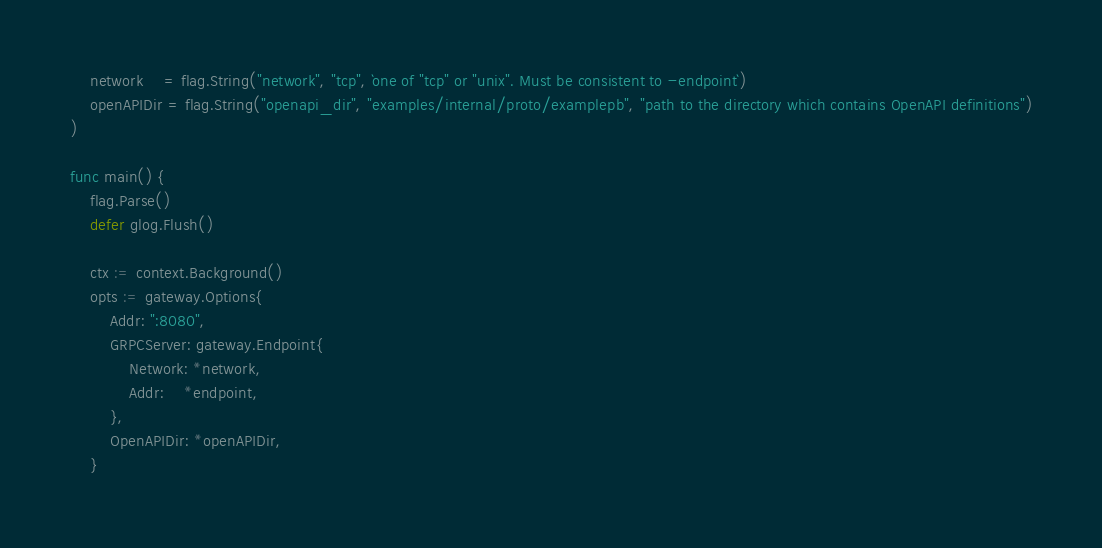Convert code to text. <code><loc_0><loc_0><loc_500><loc_500><_Go_>	network    = flag.String("network", "tcp", `one of "tcp" or "unix". Must be consistent to -endpoint`)
	openAPIDir = flag.String("openapi_dir", "examples/internal/proto/examplepb", "path to the directory which contains OpenAPI definitions")
)

func main() {
	flag.Parse()
	defer glog.Flush()

	ctx := context.Background()
	opts := gateway.Options{
		Addr: ":8080",
		GRPCServer: gateway.Endpoint{
			Network: *network,
			Addr:    *endpoint,
		},
		OpenAPIDir: *openAPIDir,
	}</code> 